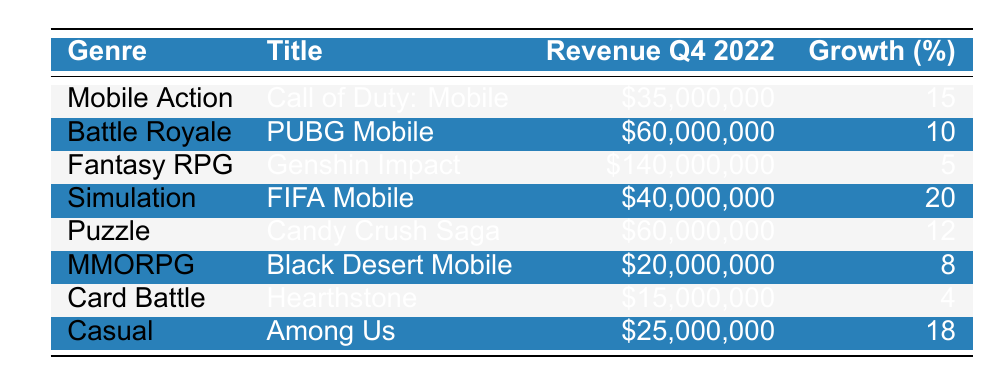What is the total revenue generated from in-game purchases for all titles combined? To find the total revenue, I need to add the revenue of all titles: 35,000,000 + 60,000,000 + 140,000,000 + 40,000,000 + 60,000,000 + 20,000,000 + 15,000,000 + 25,000,000 =  385,000,000.
Answer: 385,000,000 Which game had the highest revenue in Q4 2022? By checking the revenue column, Genshin Impact has the highest revenue of 140,000,000.
Answer: Genshin Impact What percentage growth did FIFA Mobile experience in Q4 2022? According to the table, FIFA Mobile had a growth percentage of 20.
Answer: 20 Did Candy Crush Saga experience a higher growth percentage than Hearthstone in Q4 2022? Candy Crush Saga had a growth percentage of 12 while Hearthstone had a growth percentage of 4. Thus, 12 is greater than 4.
Answer: Yes What is the average revenue generated from the games in the Simulation genre? There is only one title in the Simulation genre, FIFA Mobile, which generated 40,000,000. The average is simply 40,000,000 since there's only one value.
Answer: 40,000,000 Which genre had the lowest revenue in Q4 2022? The lowest revenue comes from Black Desert Mobile in the MMORPG genre, which generated 20,000,000.
Answer: MMORPG What is the revenue difference between the best and worst performing genres? The best performing genre, Fantasy RPG (Genshin Impact), generated 140,000,000, while the worst performing genre, Card Battle (Hearthstone), generated 15,000,000. The difference is 140,000,000 - 15,000,000 = 125,000,000.
Answer: 125,000,000 Are there more games listed with a percentage growth of 10 or higher than those below 10? There are four titles with a percentage growth of 10 or higher (Call of Duty: Mobile, PUBG Mobile, FIFA Mobile, and Among Us) and three titles with a growth percentage below 10 (Genshin Impact, Black Desert Mobile, and Hearthstone). Therefore, there are more games with higher growth.
Answer: Yes 